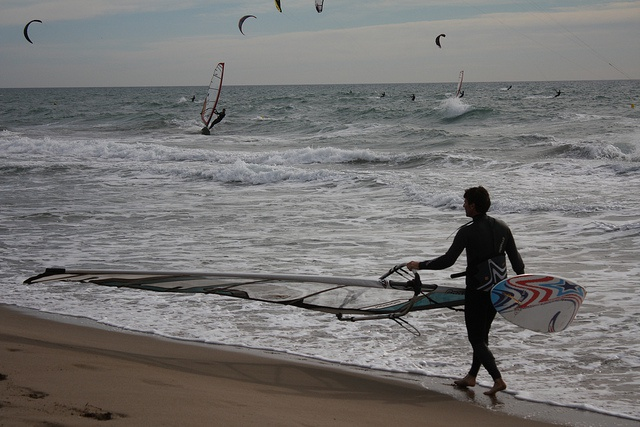Describe the objects in this image and their specific colors. I can see people in gray, black, and darkgray tones, surfboard in gray, maroon, black, and blue tones, people in gray and black tones, kite in gray and black tones, and kite in gray, black, darkgray, and maroon tones in this image. 